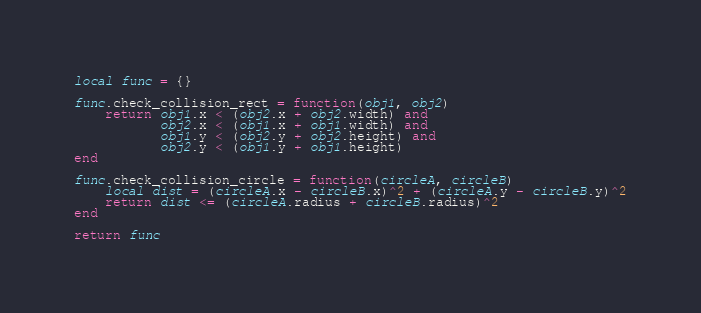Convert code to text. <code><loc_0><loc_0><loc_500><loc_500><_Lua_>local func = {}

func.check_collision_rect = function(obj1, obj2)
    return obj1.x < (obj2.x + obj2.width) and
           obj2.x < (obj1.x + obj1.width) and
           obj1.y < (obj2.y + obj2.height) and
           obj2.y < (obj1.y + obj1.height)
end

func.check_collision_circle = function(circleA, circleB)
    local dist = (circleA.x - circleB.x)^2 + (circleA.y - circleB.y)^2
    return dist <= (circleA.radius + circleB.radius)^2
end

return func
</code> 